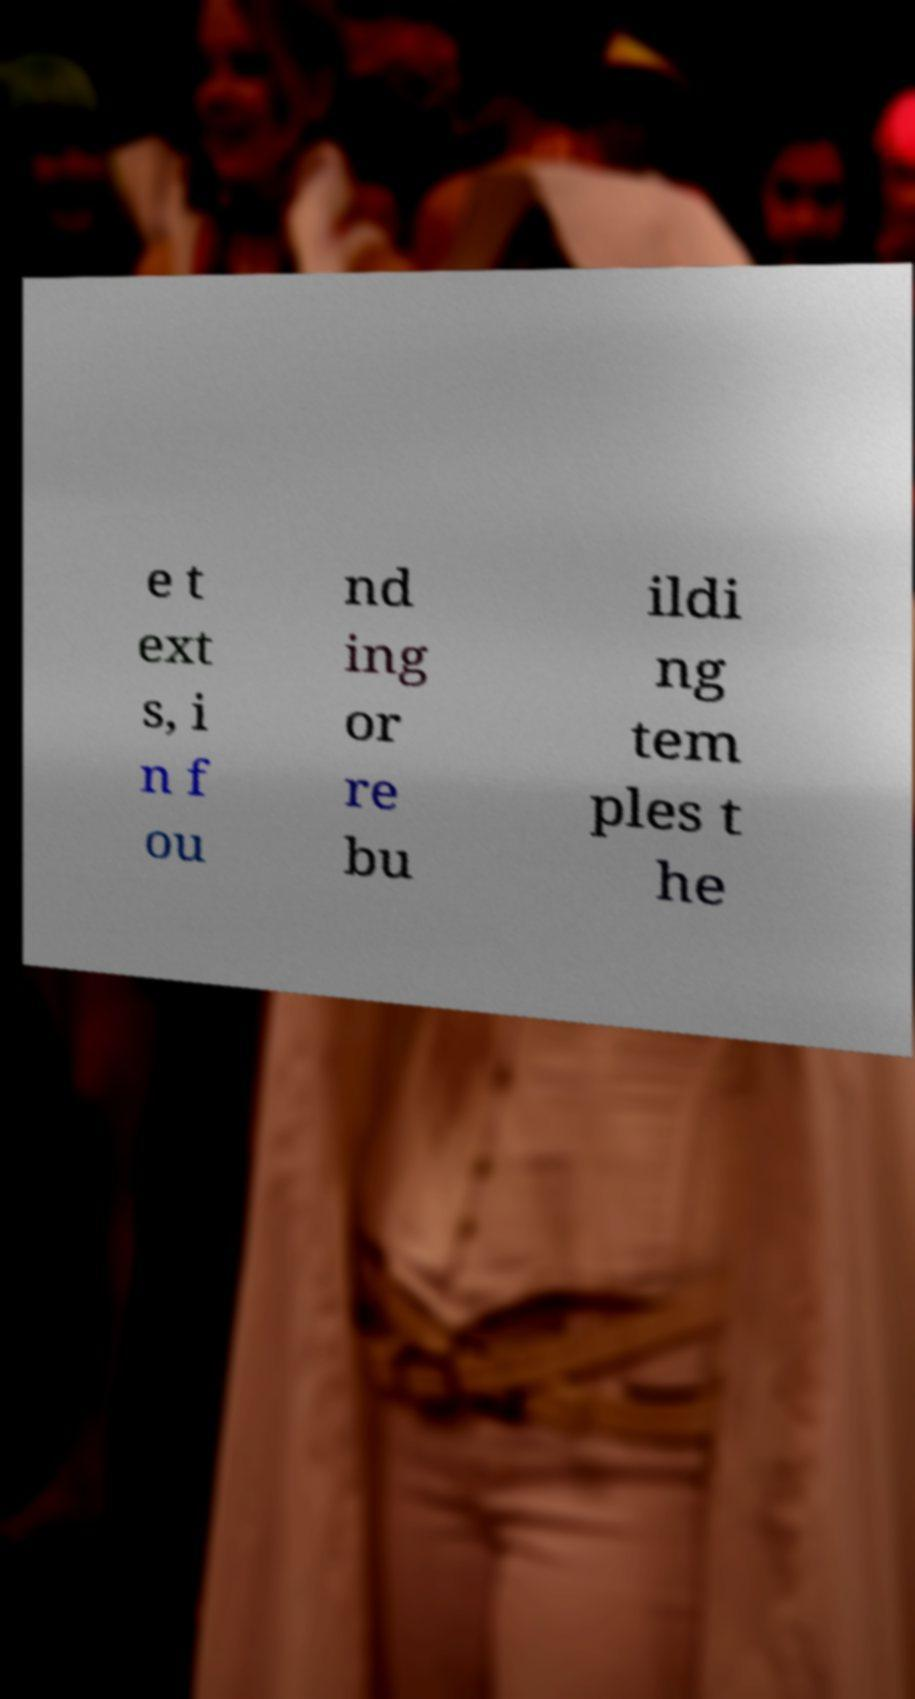For documentation purposes, I need the text within this image transcribed. Could you provide that? e t ext s, i n f ou nd ing or re bu ildi ng tem ples t he 